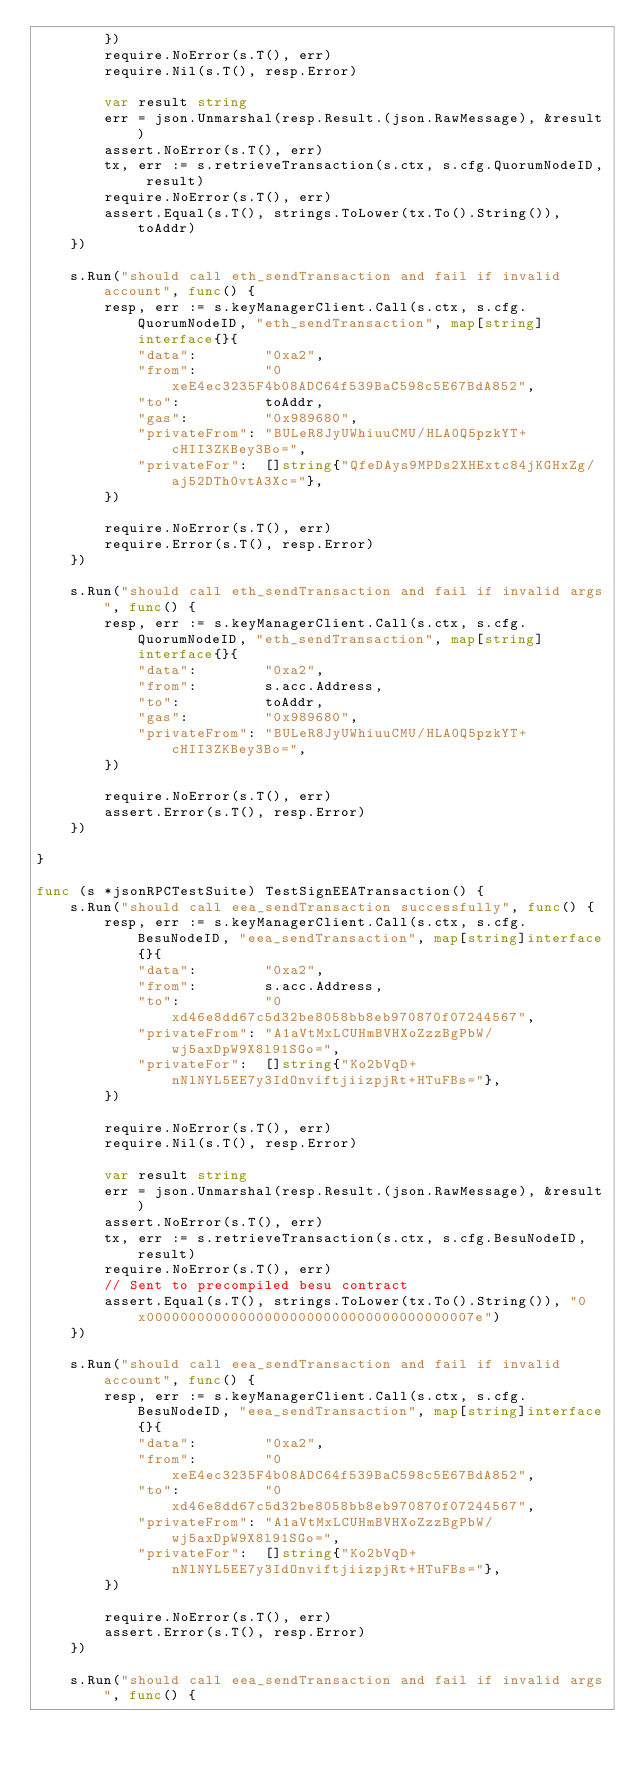<code> <loc_0><loc_0><loc_500><loc_500><_Go_>		})
		require.NoError(s.T(), err)
		require.Nil(s.T(), resp.Error)

		var result string
		err = json.Unmarshal(resp.Result.(json.RawMessage), &result)
		assert.NoError(s.T(), err)
		tx, err := s.retrieveTransaction(s.ctx, s.cfg.QuorumNodeID, result)
		require.NoError(s.T(), err)
		assert.Equal(s.T(), strings.ToLower(tx.To().String()), toAddr)
	})

	s.Run("should call eth_sendTransaction and fail if invalid account", func() {
		resp, err := s.keyManagerClient.Call(s.ctx, s.cfg.QuorumNodeID, "eth_sendTransaction", map[string]interface{}{
			"data":        "0xa2",
			"from":        "0xeE4ec3235F4b08ADC64f539BaC598c5E67BdA852",
			"to":          toAddr,
			"gas":         "0x989680",
			"privateFrom": "BULeR8JyUWhiuuCMU/HLA0Q5pzkYT+cHII3ZKBey3Bo=",
			"privateFor":  []string{"QfeDAys9MPDs2XHExtc84jKGHxZg/aj52DTh0vtA3Xc="},
		})

		require.NoError(s.T(), err)
		require.Error(s.T(), resp.Error)
	})

	s.Run("should call eth_sendTransaction and fail if invalid args", func() {
		resp, err := s.keyManagerClient.Call(s.ctx, s.cfg.QuorumNodeID, "eth_sendTransaction", map[string]interface{}{
			"data":        "0xa2",
			"from":        s.acc.Address,
			"to":          toAddr,
			"gas":         "0x989680",
			"privateFrom": "BULeR8JyUWhiuuCMU/HLA0Q5pzkYT+cHII3ZKBey3Bo=",
		})

		require.NoError(s.T(), err)
		assert.Error(s.T(), resp.Error)
	})

}

func (s *jsonRPCTestSuite) TestSignEEATransaction() {
	s.Run("should call eea_sendTransaction successfully", func() {
		resp, err := s.keyManagerClient.Call(s.ctx, s.cfg.BesuNodeID, "eea_sendTransaction", map[string]interface{}{
			"data":        "0xa2",
			"from":        s.acc.Address,
			"to":          "0xd46e8dd67c5d32be8058bb8eb970870f07244567",
			"privateFrom": "A1aVtMxLCUHmBVHXoZzzBgPbW/wj5axDpW9X8l91SGo=",
			"privateFor":  []string{"Ko2bVqD+nNlNYL5EE7y3IdOnviftjiizpjRt+HTuFBs="},
		})

		require.NoError(s.T(), err)
		require.Nil(s.T(), resp.Error)

		var result string
		err = json.Unmarshal(resp.Result.(json.RawMessage), &result)
		assert.NoError(s.T(), err)
		tx, err := s.retrieveTransaction(s.ctx, s.cfg.BesuNodeID, result)
		require.NoError(s.T(), err)
		// Sent to precompiled besu contract
		assert.Equal(s.T(), strings.ToLower(tx.To().String()), "0x000000000000000000000000000000000000007e")
	})

	s.Run("should call eea_sendTransaction and fail if invalid account", func() {
		resp, err := s.keyManagerClient.Call(s.ctx, s.cfg.BesuNodeID, "eea_sendTransaction", map[string]interface{}{
			"data":        "0xa2",
			"from":        "0xeE4ec3235F4b08ADC64f539BaC598c5E67BdA852",
			"to":          "0xd46e8dd67c5d32be8058bb8eb970870f07244567",
			"privateFrom": "A1aVtMxLCUHmBVHXoZzzBgPbW/wj5axDpW9X8l91SGo=",
			"privateFor":  []string{"Ko2bVqD+nNlNYL5EE7y3IdOnviftjiizpjRt+HTuFBs="},
		})

		require.NoError(s.T(), err)
		assert.Error(s.T(), resp.Error)
	})

	s.Run("should call eea_sendTransaction and fail if invalid args", func() {</code> 